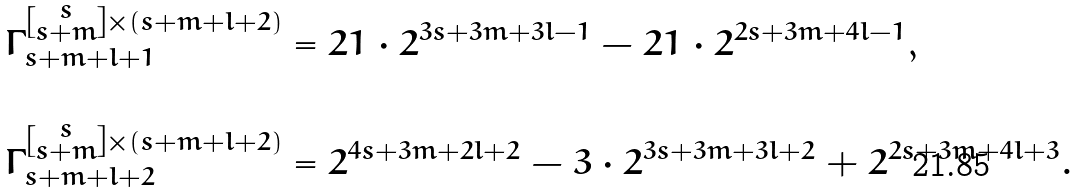Convert formula to latex. <formula><loc_0><loc_0><loc_500><loc_500>\Gamma _ { s + m + l + 1 } ^ { \left [ \substack { s \\ s + m } \right ] \times ( s + m + l + 2 ) } & = 2 1 \cdot 2 ^ { 3 s + 3 m + 3 l - 1 } - 2 1 \cdot 2 ^ { 2 s + 3 m + 4 l - 1 } , \\ & \\ \Gamma _ { s + m + l + 2 } ^ { \left [ \substack { s \\ s + m } \right ] \times ( s + m + l + 2 ) } & = 2 ^ { 4 s + 3 m + 2 l + 2 } - 3 \cdot 2 ^ { 3 s + 3 m + 3 l + 2 } + 2 ^ { 2 s + 3 m + 4 l + 3 } . \\ &</formula> 